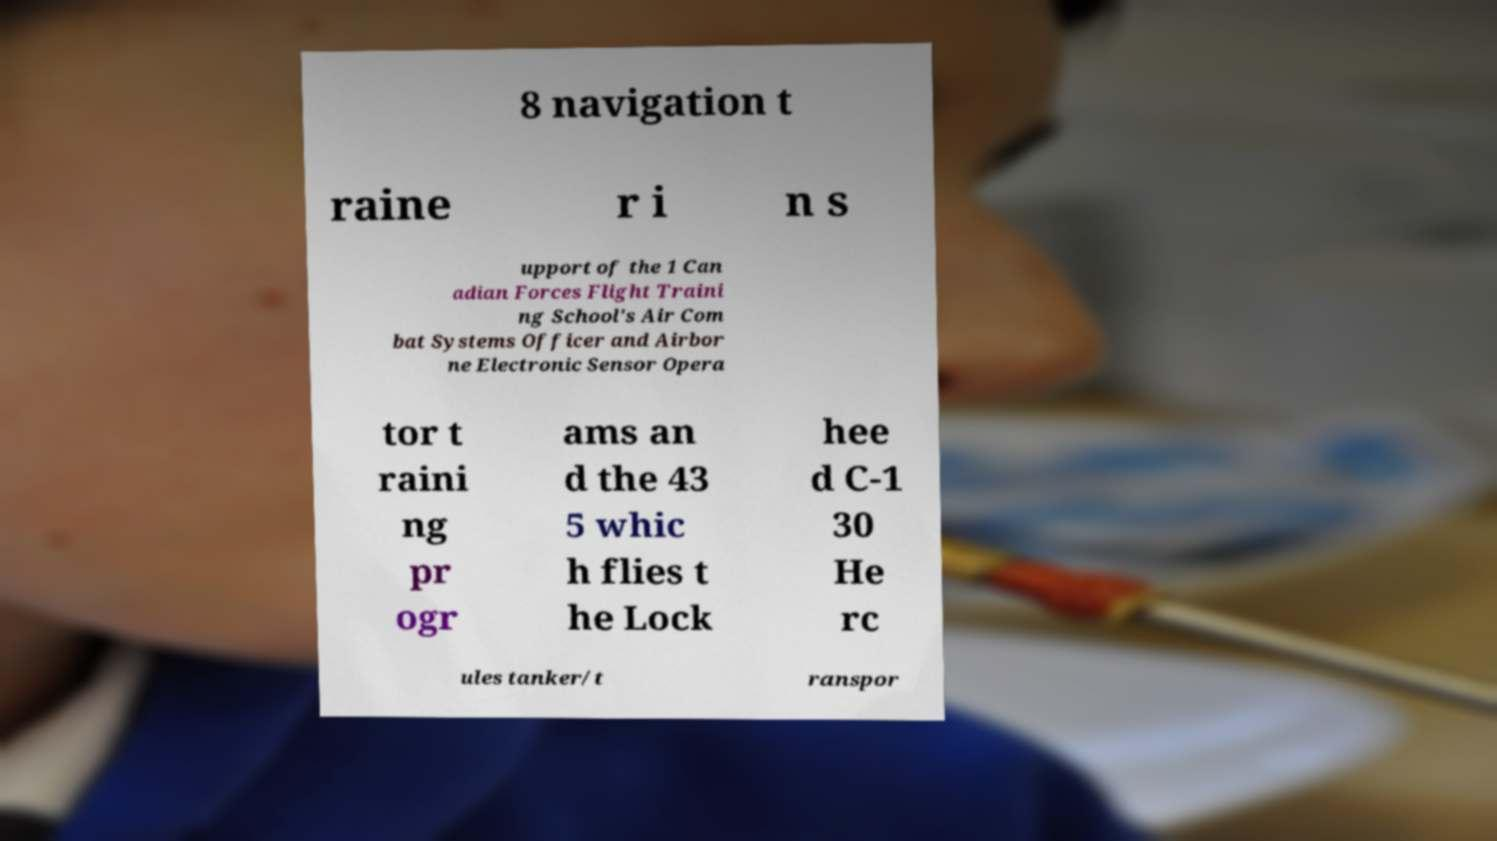Could you extract and type out the text from this image? 8 navigation t raine r i n s upport of the 1 Can adian Forces Flight Traini ng School's Air Com bat Systems Officer and Airbor ne Electronic Sensor Opera tor t raini ng pr ogr ams an d the 43 5 whic h flies t he Lock hee d C-1 30 He rc ules tanker/t ranspor 